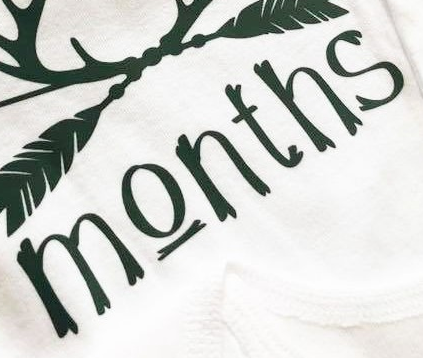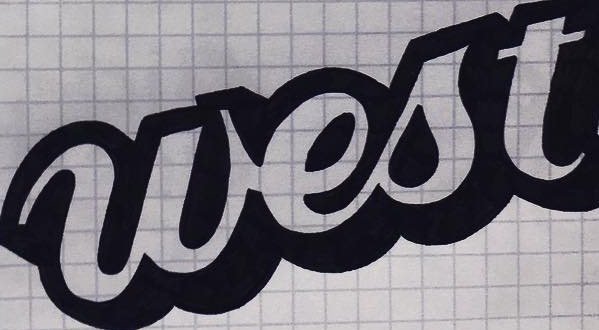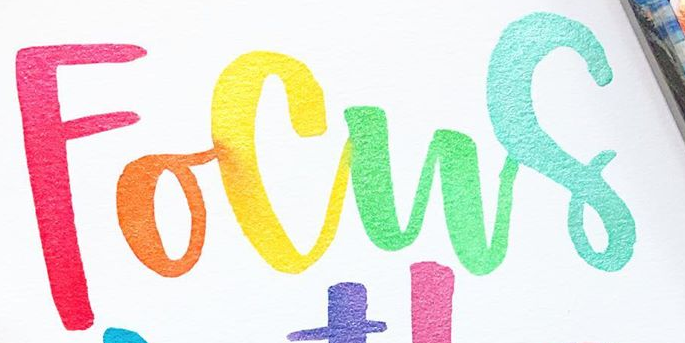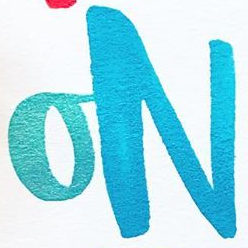What text appears in these images from left to right, separated by a semicolon? Months; west; Focus; ON 